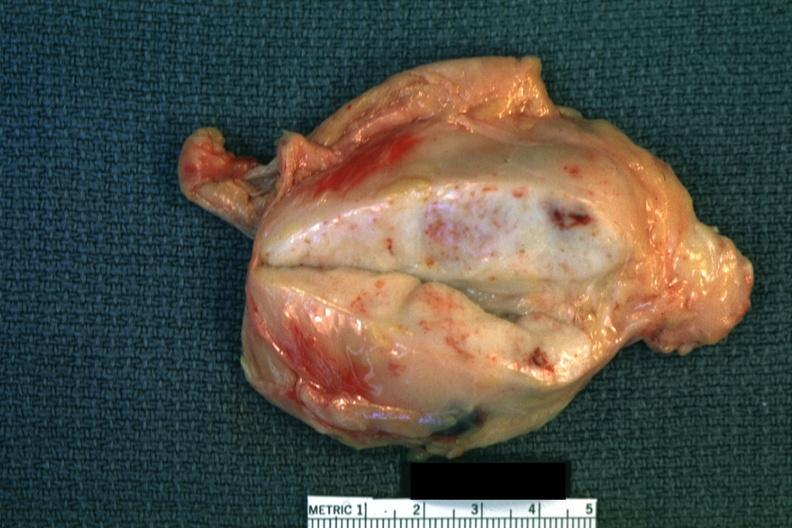does adenoma sebaceum enlarge white node with focal necrosis quite good?
Answer the question using a single word or phrase. No 